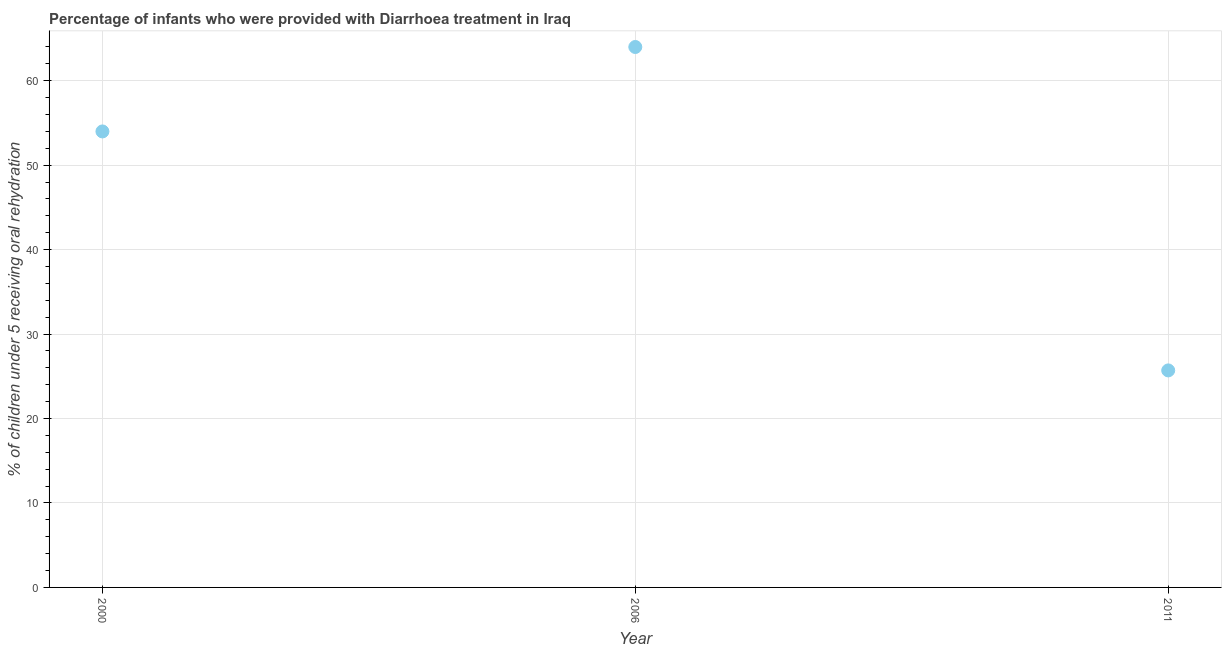Across all years, what is the minimum percentage of children who were provided with treatment diarrhoea?
Keep it short and to the point. 25.7. In which year was the percentage of children who were provided with treatment diarrhoea minimum?
Ensure brevity in your answer.  2011. What is the sum of the percentage of children who were provided with treatment diarrhoea?
Keep it short and to the point. 143.7. What is the difference between the percentage of children who were provided with treatment diarrhoea in 2000 and 2011?
Your answer should be very brief. 28.3. What is the average percentage of children who were provided with treatment diarrhoea per year?
Your response must be concise. 47.9. In how many years, is the percentage of children who were provided with treatment diarrhoea greater than 16 %?
Offer a terse response. 3. Do a majority of the years between 2011 and 2006 (inclusive) have percentage of children who were provided with treatment diarrhoea greater than 36 %?
Ensure brevity in your answer.  No. What is the ratio of the percentage of children who were provided with treatment diarrhoea in 2000 to that in 2011?
Your response must be concise. 2.1. Is the percentage of children who were provided with treatment diarrhoea in 2000 less than that in 2006?
Your answer should be compact. Yes. What is the difference between the highest and the lowest percentage of children who were provided with treatment diarrhoea?
Your answer should be compact. 38.3. In how many years, is the percentage of children who were provided with treatment diarrhoea greater than the average percentage of children who were provided with treatment diarrhoea taken over all years?
Provide a succinct answer. 2. Does the percentage of children who were provided with treatment diarrhoea monotonically increase over the years?
Your answer should be very brief. No. What is the difference between two consecutive major ticks on the Y-axis?
Keep it short and to the point. 10. Does the graph contain grids?
Give a very brief answer. Yes. What is the title of the graph?
Your answer should be very brief. Percentage of infants who were provided with Diarrhoea treatment in Iraq. What is the label or title of the Y-axis?
Your answer should be very brief. % of children under 5 receiving oral rehydration. What is the % of children under 5 receiving oral rehydration in 2000?
Your response must be concise. 54. What is the % of children under 5 receiving oral rehydration in 2006?
Your answer should be compact. 64. What is the % of children under 5 receiving oral rehydration in 2011?
Offer a terse response. 25.7. What is the difference between the % of children under 5 receiving oral rehydration in 2000 and 2006?
Offer a terse response. -10. What is the difference between the % of children under 5 receiving oral rehydration in 2000 and 2011?
Offer a very short reply. 28.3. What is the difference between the % of children under 5 receiving oral rehydration in 2006 and 2011?
Ensure brevity in your answer.  38.3. What is the ratio of the % of children under 5 receiving oral rehydration in 2000 to that in 2006?
Make the answer very short. 0.84. What is the ratio of the % of children under 5 receiving oral rehydration in 2000 to that in 2011?
Ensure brevity in your answer.  2.1. What is the ratio of the % of children under 5 receiving oral rehydration in 2006 to that in 2011?
Offer a terse response. 2.49. 